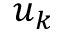<formula> <loc_0><loc_0><loc_500><loc_500>u _ { k }</formula> 